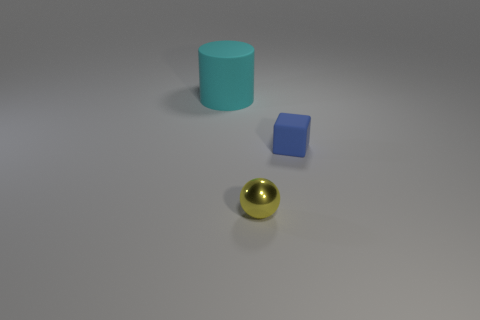Are there any other things that are the same size as the matte cylinder?
Ensure brevity in your answer.  No. How many other objects are the same color as the big matte object?
Ensure brevity in your answer.  0. What color is the rubber thing to the right of the cyan cylinder?
Offer a very short reply. Blue. How many cyan objects are either rubber things or tiny blocks?
Make the answer very short. 1. What is the color of the cylinder?
Provide a short and direct response. Cyan. Are there any other things that are the same material as the small yellow thing?
Your answer should be compact. No. Are there fewer small rubber things that are behind the blue matte thing than large objects that are left of the sphere?
Your answer should be compact. Yes. What is the shape of the thing that is both on the right side of the large rubber object and behind the tiny yellow metal ball?
Your answer should be very brief. Cube. How many other cyan objects have the same shape as the cyan rubber object?
Offer a terse response. 0. There is a cyan cylinder that is the same material as the block; what is its size?
Make the answer very short. Large. 